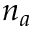<formula> <loc_0><loc_0><loc_500><loc_500>n _ { a }</formula> 